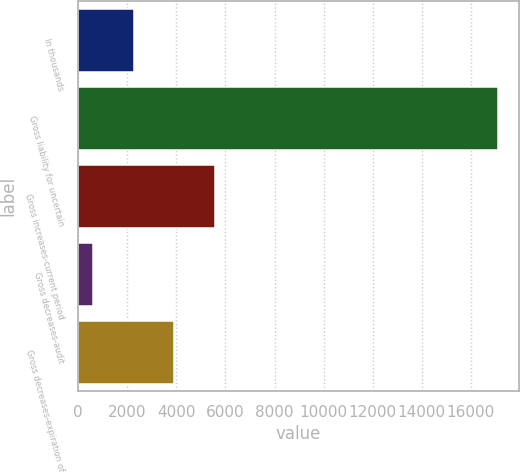Convert chart to OTSL. <chart><loc_0><loc_0><loc_500><loc_500><bar_chart><fcel>In thousands<fcel>Gross liability for uncertain<fcel>Gross increases-current period<fcel>Gross decreases-audit<fcel>Gross decreases-expiration of<nl><fcel>2257.6<fcel>17102<fcel>5578.8<fcel>597<fcel>3918.2<nl></chart> 